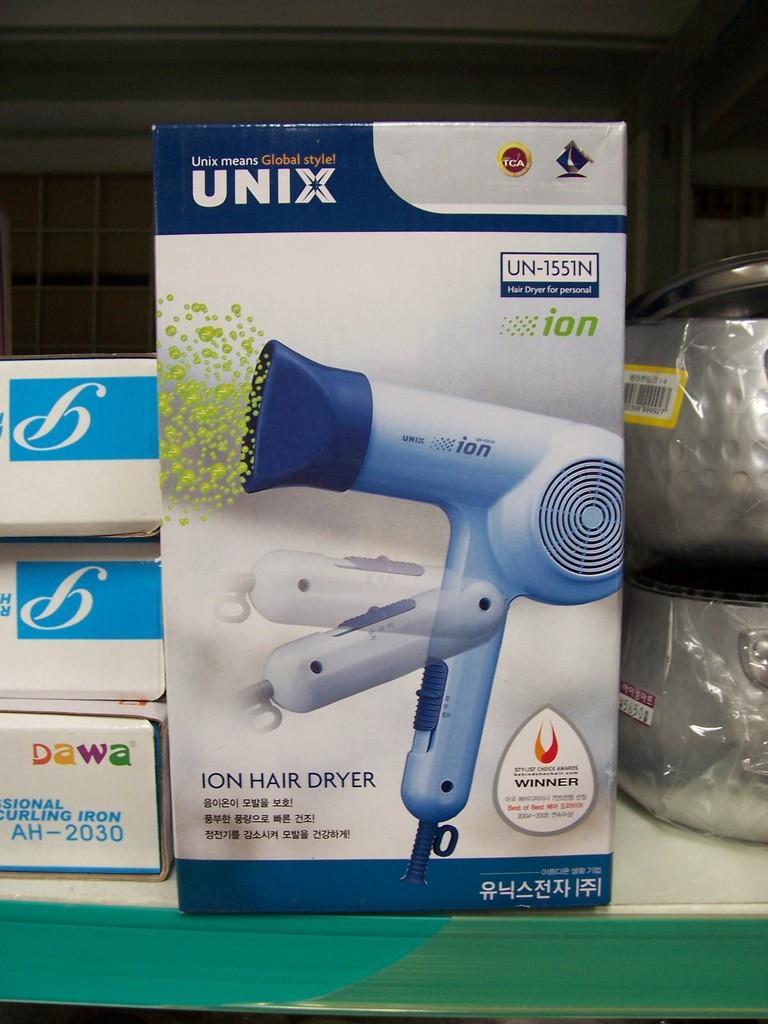Please provide a concise description of this image. In the center of the image we can see some boxes, vessels are present on the table. In the background of the image there is a wall. At the top of the image there is a roof. 